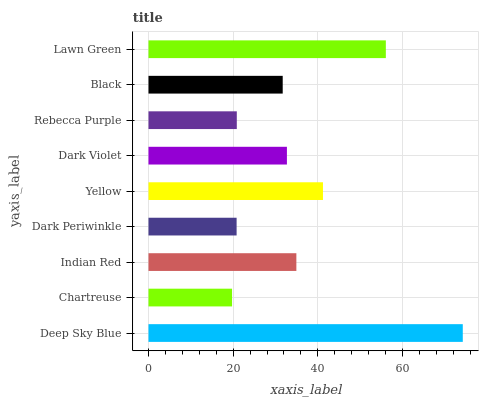Is Chartreuse the minimum?
Answer yes or no. Yes. Is Deep Sky Blue the maximum?
Answer yes or no. Yes. Is Indian Red the minimum?
Answer yes or no. No. Is Indian Red the maximum?
Answer yes or no. No. Is Indian Red greater than Chartreuse?
Answer yes or no. Yes. Is Chartreuse less than Indian Red?
Answer yes or no. Yes. Is Chartreuse greater than Indian Red?
Answer yes or no. No. Is Indian Red less than Chartreuse?
Answer yes or no. No. Is Dark Violet the high median?
Answer yes or no. Yes. Is Dark Violet the low median?
Answer yes or no. Yes. Is Rebecca Purple the high median?
Answer yes or no. No. Is Deep Sky Blue the low median?
Answer yes or no. No. 